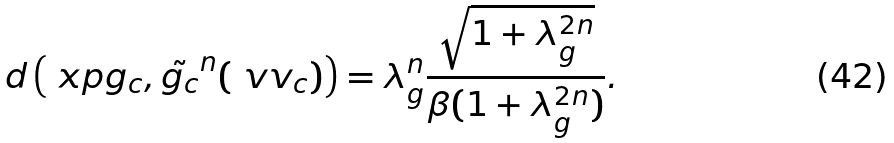Convert formula to latex. <formula><loc_0><loc_0><loc_500><loc_500>d \left ( \ x p { g _ { c } } , \tilde { g _ { c } } ^ { n } ( \ v v _ { c } ) \right ) = \lambda ^ { n } _ { g } \frac { \sqrt { 1 + \lambda ^ { 2 n } _ { g } } } { \beta ( 1 + \lambda _ { g } ^ { 2 n } ) } .</formula> 